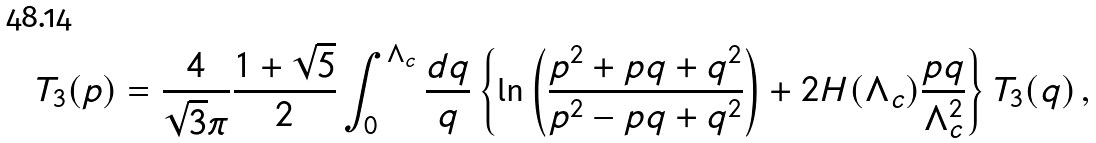Convert formula to latex. <formula><loc_0><loc_0><loc_500><loc_500>T _ { 3 } ( p ) = \frac { 4 } { \sqrt { 3 } \pi } \frac { 1 + \sqrt { 5 } } { 2 } \int _ { 0 } ^ { \Lambda _ { c } } \frac { d q } { q } \left \{ \ln \left ( \frac { p ^ { 2 } + p q + q ^ { 2 } } { p ^ { 2 } - p q + q ^ { 2 } } \right ) + 2 H ( \Lambda _ { c } ) \frac { p q } { \Lambda _ { c } ^ { 2 } } \right \} T _ { 3 } ( q ) \, ,</formula> 